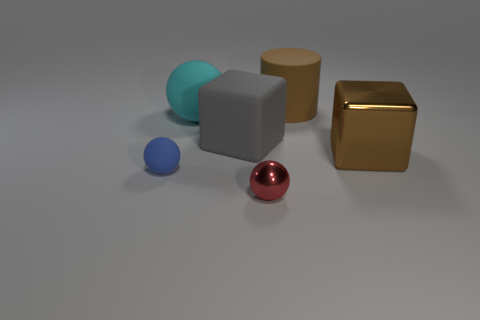Subtract all metal spheres. How many spheres are left? 2 Add 2 large brown metal objects. How many objects exist? 8 Subtract all red balls. How many balls are left? 2 Subtract all cylinders. How many objects are left? 5 Subtract 1 blocks. How many blocks are left? 1 Subtract all blue balls. How many gray blocks are left? 1 Subtract all big green spheres. Subtract all gray rubber things. How many objects are left? 5 Add 1 brown blocks. How many brown blocks are left? 2 Add 2 cubes. How many cubes exist? 4 Subtract 0 red cubes. How many objects are left? 6 